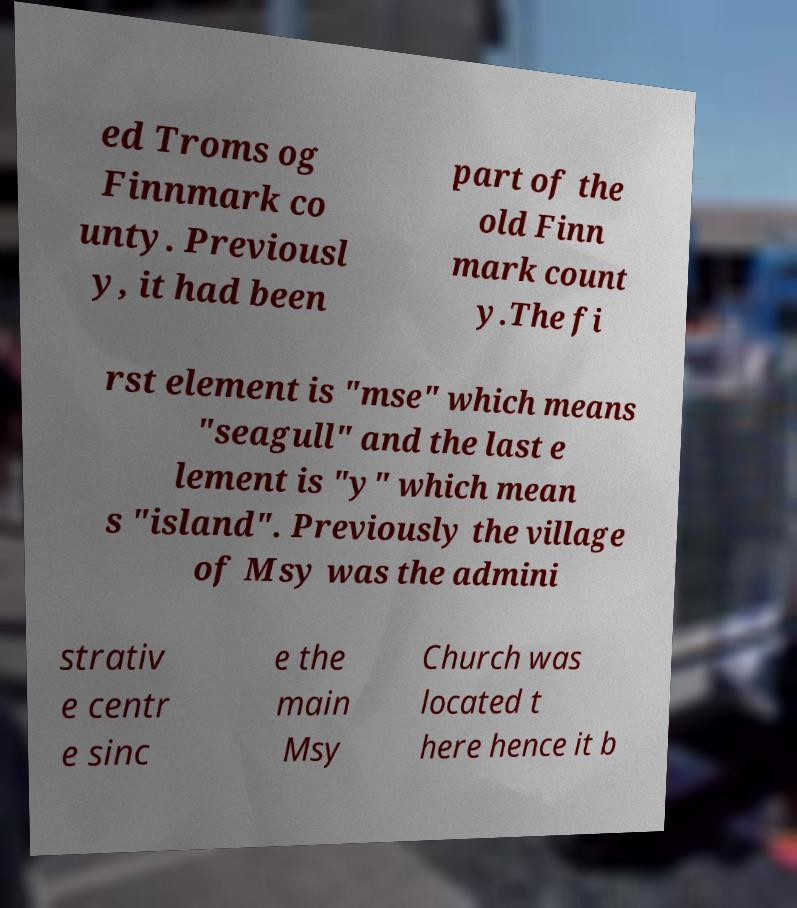Can you read and provide the text displayed in the image?This photo seems to have some interesting text. Can you extract and type it out for me? ed Troms og Finnmark co unty. Previousl y, it had been part of the old Finn mark count y.The fi rst element is "mse" which means "seagull" and the last e lement is "y" which mean s "island". Previously the village of Msy was the admini strativ e centr e sinc e the main Msy Church was located t here hence it b 